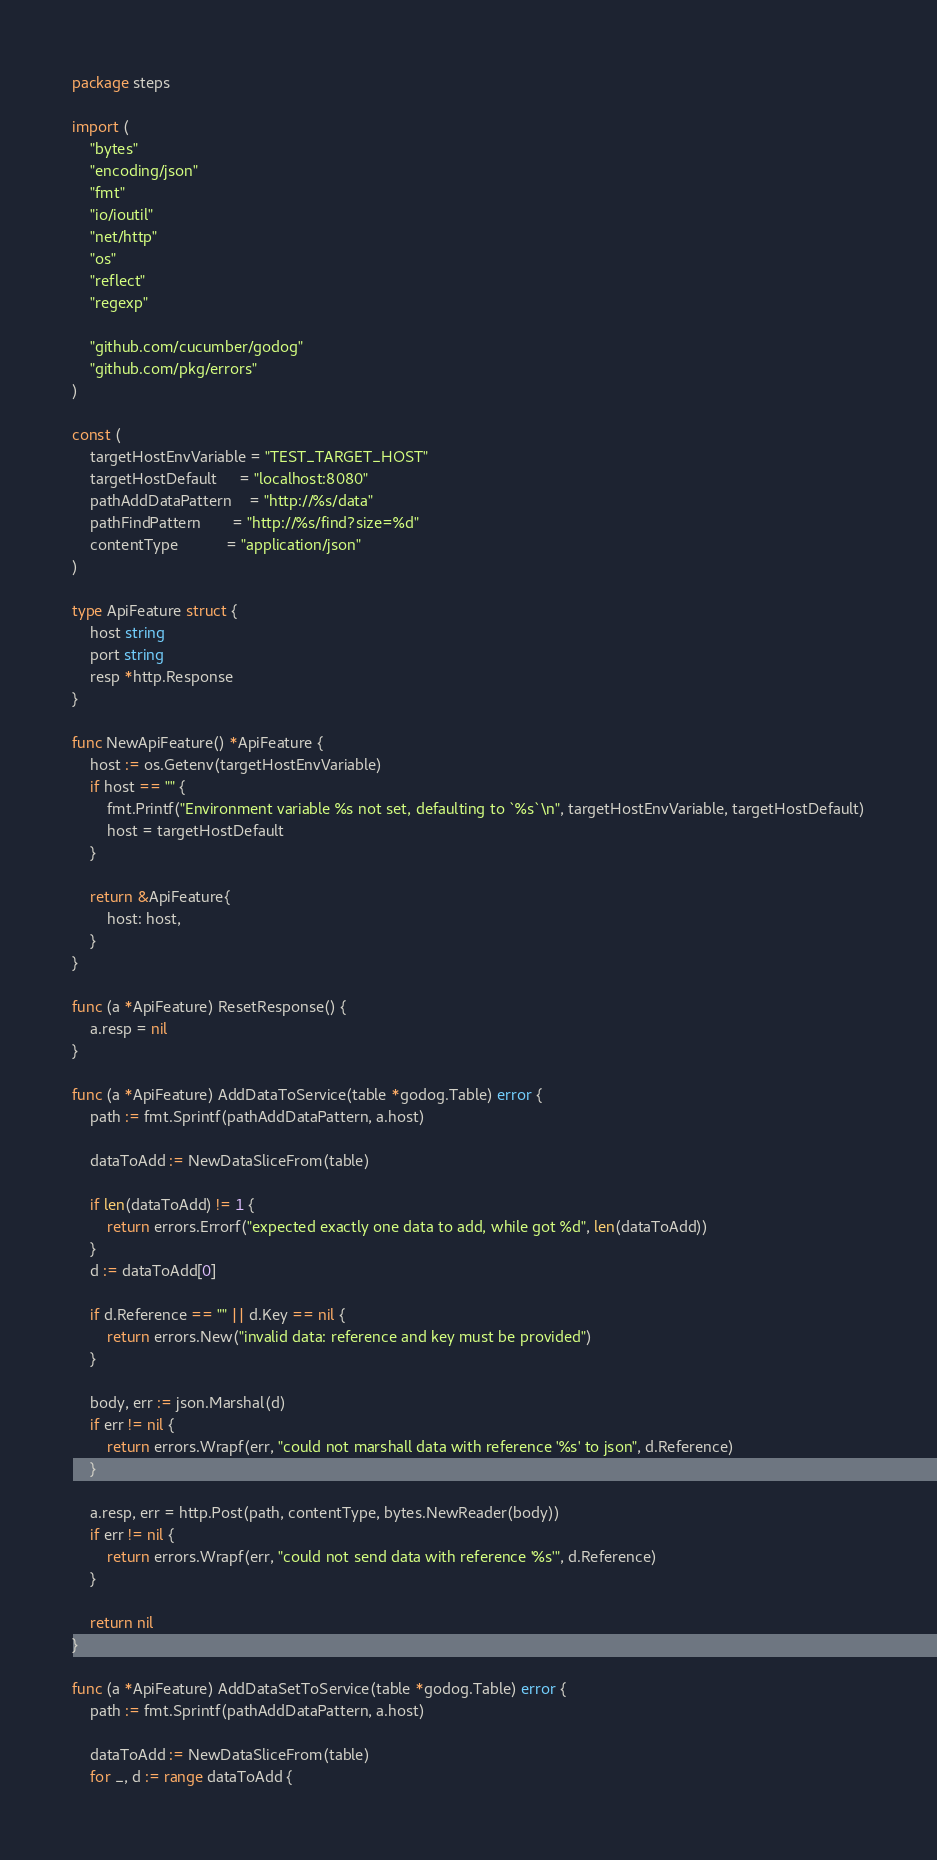Convert code to text. <code><loc_0><loc_0><loc_500><loc_500><_Go_>package steps

import (
	"bytes"
	"encoding/json"
	"fmt"
	"io/ioutil"
	"net/http"
	"os"
	"reflect"
	"regexp"

	"github.com/cucumber/godog"
	"github.com/pkg/errors"
)

const (
	targetHostEnvVariable = "TEST_TARGET_HOST"
	targetHostDefault     = "localhost:8080"
	pathAddDataPattern    = "http://%s/data"
	pathFindPattern       = "http://%s/find?size=%d"
	contentType           = "application/json"
)

type ApiFeature struct {
	host string
	port string
	resp *http.Response
}

func NewApiFeature() *ApiFeature {
	host := os.Getenv(targetHostEnvVariable)
	if host == "" {
		fmt.Printf("Environment variable %s not set, defaulting to `%s`\n", targetHostEnvVariable, targetHostDefault)
		host = targetHostDefault
	}

	return &ApiFeature{
		host: host,
	}
}

func (a *ApiFeature) ResetResponse() {
	a.resp = nil
}

func (a *ApiFeature) AddDataToService(table *godog.Table) error {
	path := fmt.Sprintf(pathAddDataPattern, a.host)

	dataToAdd := NewDataSliceFrom(table)

	if len(dataToAdd) != 1 {
		return errors.Errorf("expected exactly one data to add, while got %d", len(dataToAdd))
	}
	d := dataToAdd[0]

	if d.Reference == "" || d.Key == nil {
		return errors.New("invalid data: reference and key must be provided")
	}

	body, err := json.Marshal(d)
	if err != nil {
		return errors.Wrapf(err, "could not marshall data with reference '%s' to json", d.Reference)
	}

	a.resp, err = http.Post(path, contentType, bytes.NewReader(body))
	if err != nil {
		return errors.Wrapf(err, "could not send data with reference '%s'", d.Reference)
	}

	return nil
}

func (a *ApiFeature) AddDataSetToService(table *godog.Table) error {
	path := fmt.Sprintf(pathAddDataPattern, a.host)

	dataToAdd := NewDataSliceFrom(table)
	for _, d := range dataToAdd {</code> 